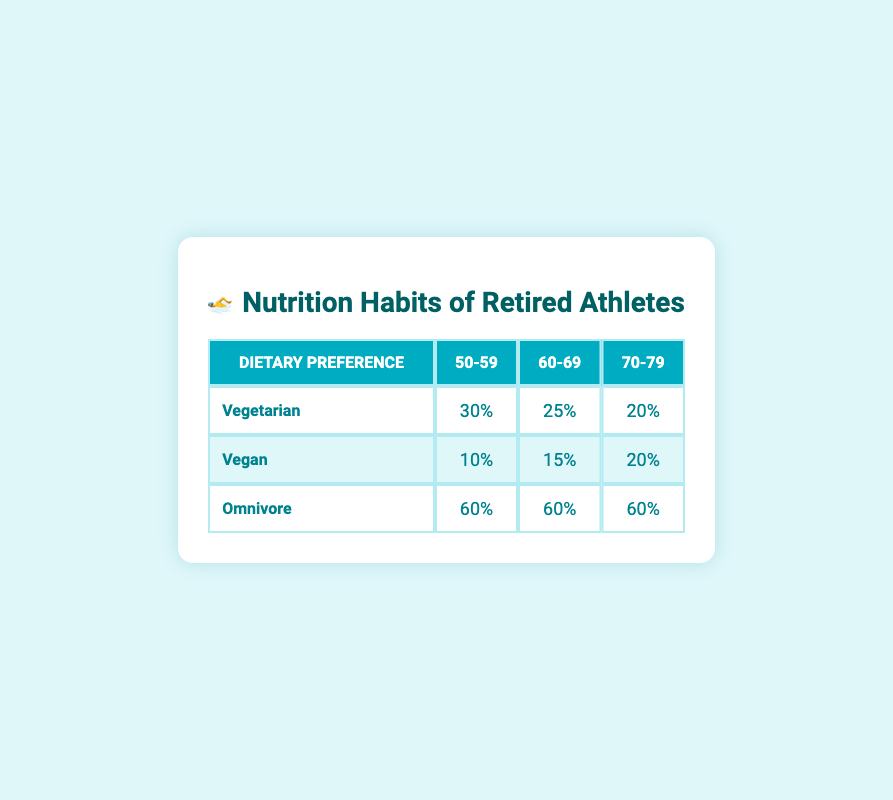What percentage of the 50-59 age group are omnivores? In the table, the percentage for omnivores in the 50-59 age group is listed directly under the Omnivore row and the 50-59 column. It is 60%.
Answer: 60% Which age group has the highest percentage of vegetarians? To find the age group with the highest percentage of vegetarians, compare the percentages across all age groups in the Vegetarian row: 30% for 50-59, 25% for 60-69, and 20% for 70-79. The highest is 30% for the 50-59 age group.
Answer: 50-59 Is it true that the percentage of vegans in the 70-79 age group is higher than in the 60-69 age group? Checking the table reveals that the vegan percentage for 70-79 is 20%, while for 60-69, it is 15%. Since 20% is greater than 15%, the statement is true.
Answer: Yes What is the average percentage of omnivores across all age groups? To find the average, sum the percentages of omnivores from all age groups: 60% (50-59) + 60% (60-69) + 60% (70-79) = 180%. Since there are three age groups, divide by 3: 180% / 3 = 60%.
Answer: 60% Which dietary preference shows the lowest percentage in the age group 60-69? In the 60-69 age group, the percentages listed are 25% for vegetarians, 15% for vegans, and 60% for omnivores. The lowest percentage is 15% for vegans.
Answer: Vegan 